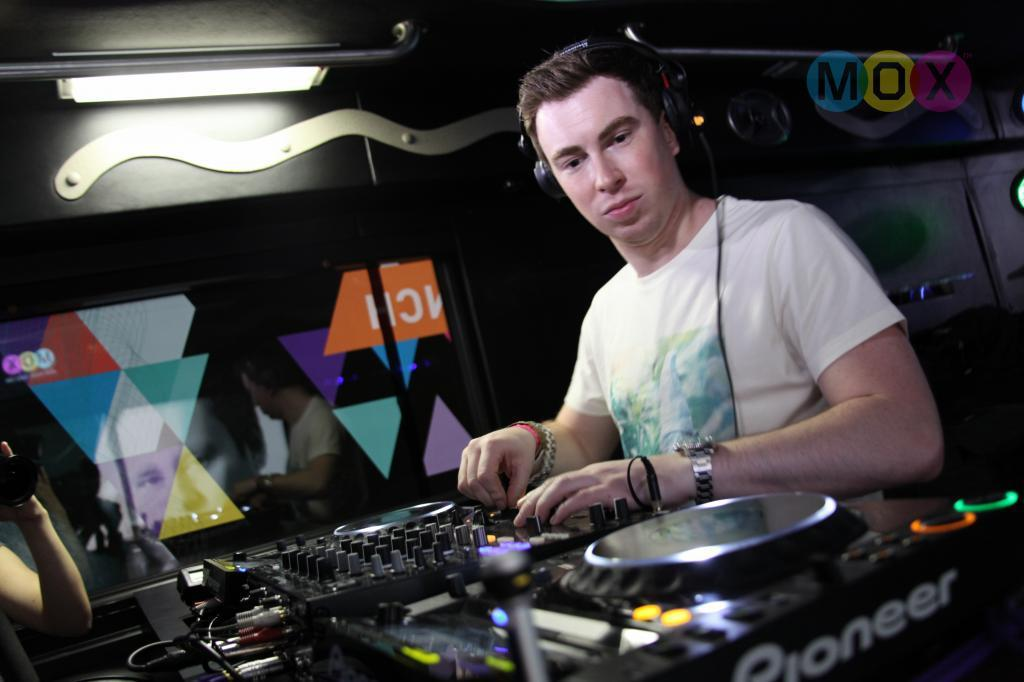What is the person in the image doing? The person is wearing a headset and a watch, and there is a DJ mixer in front of them, so they are likely DJing. What can be seen on the person's head? The person is wearing a headset. What accessory is the person wearing on their wrist? The person is wearing a watch. What is located in front of the person? There is a DJ mixer in front of the person. What is visible in the background of the image? There is a glass wall in the background. What is present on the left side of the image? There is a person's hand with a camera on the left side of the image. What type of plants can be seen growing on the dock in the image? There is no dock or plants present in the image. 